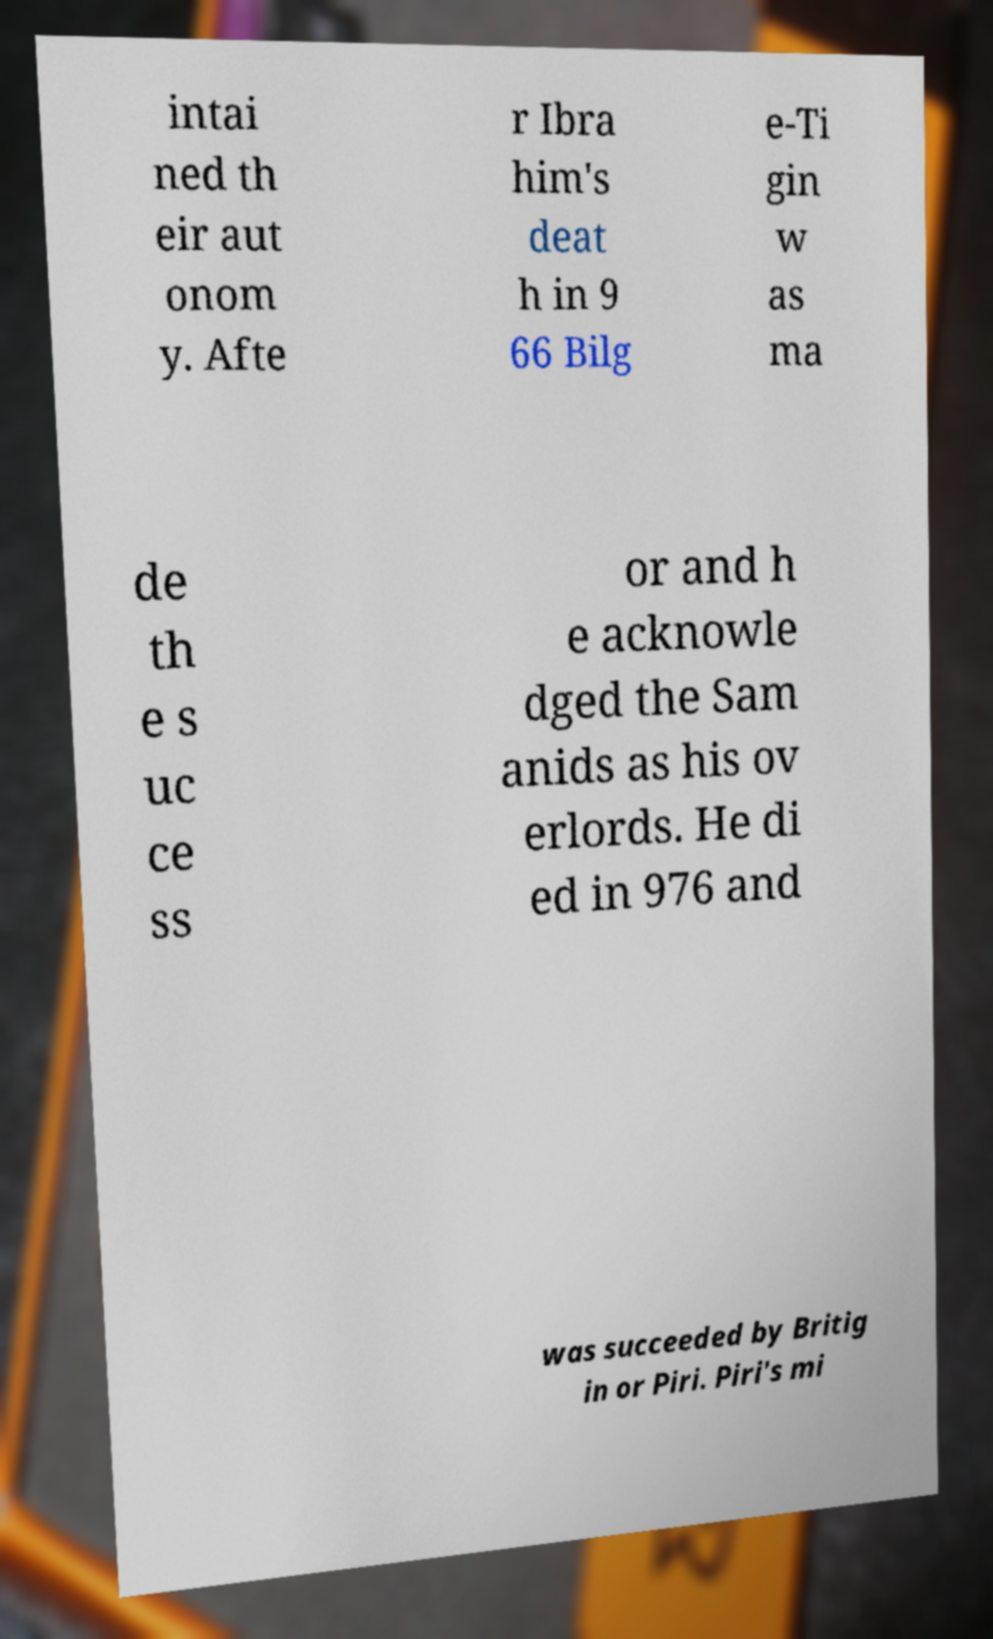Can you accurately transcribe the text from the provided image for me? intai ned th eir aut onom y. Afte r Ibra him's deat h in 9 66 Bilg e-Ti gin w as ma de th e s uc ce ss or and h e acknowle dged the Sam anids as his ov erlords. He di ed in 976 and was succeeded by Britig in or Piri. Piri's mi 